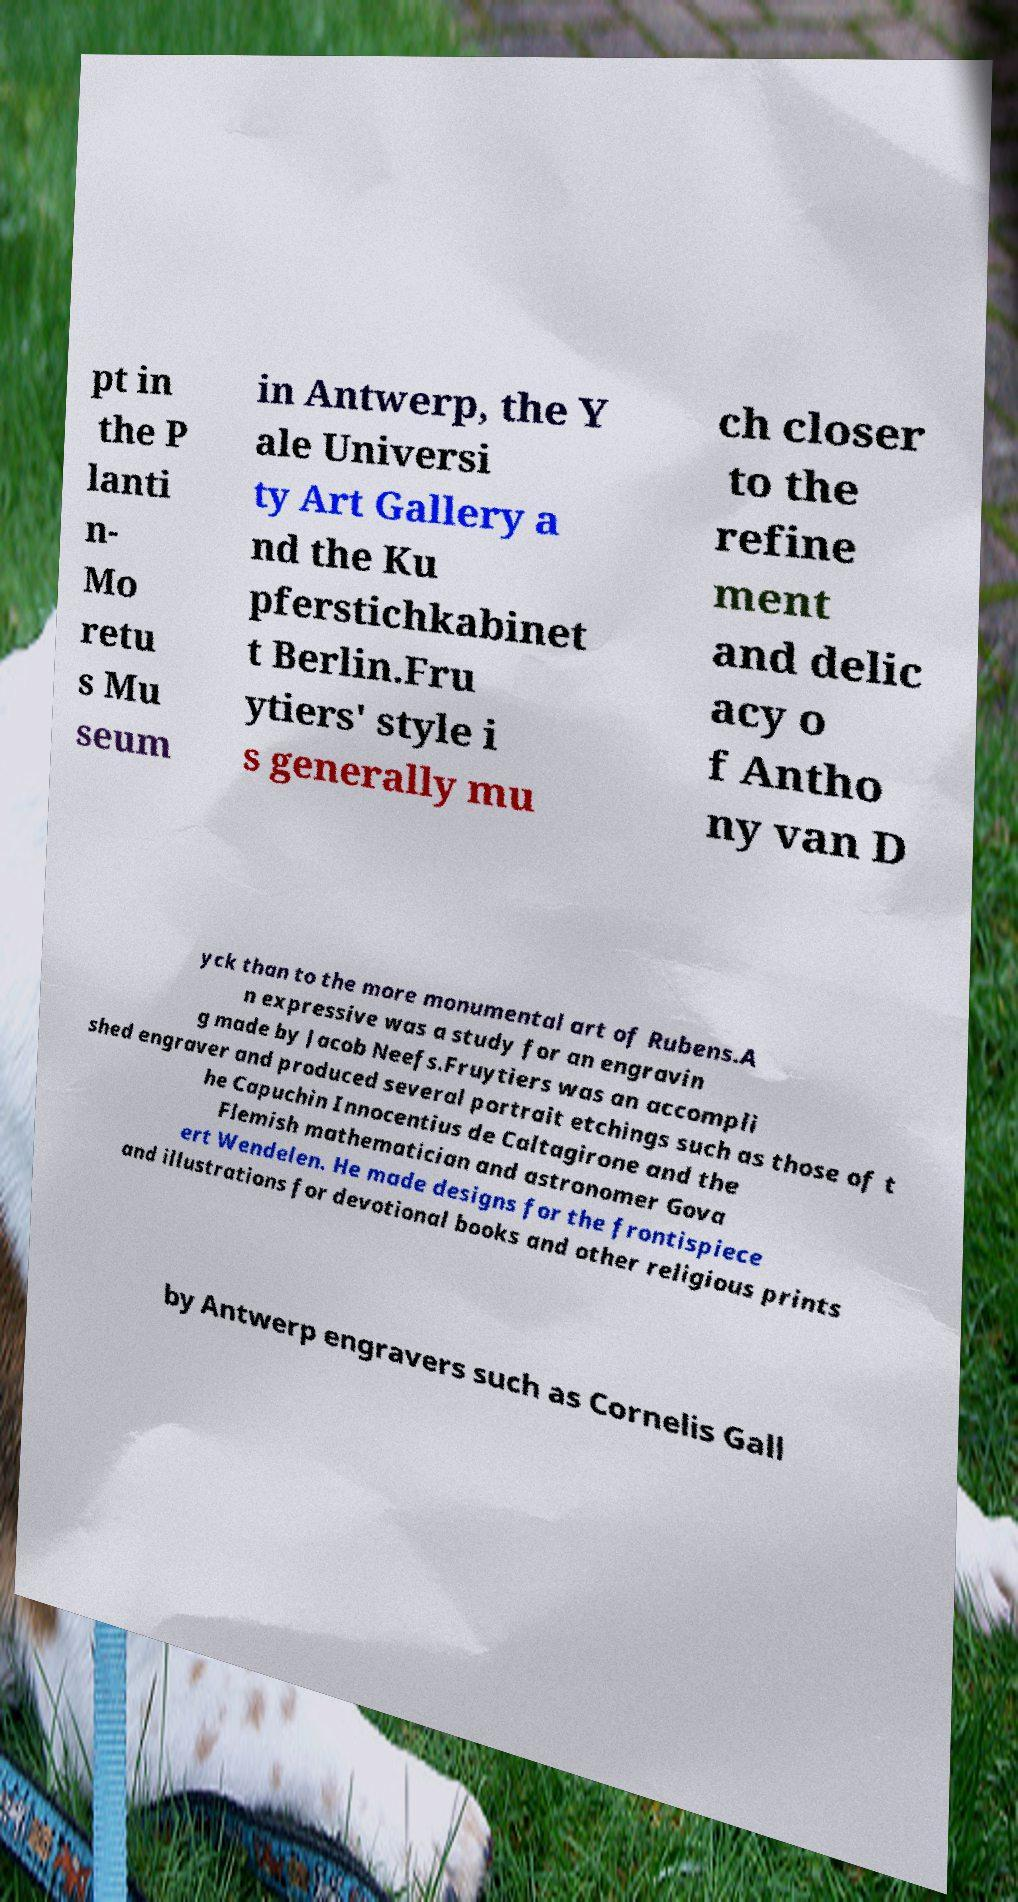Can you accurately transcribe the text from the provided image for me? pt in the P lanti n- Mo retu s Mu seum in Antwerp, the Y ale Universi ty Art Gallery a nd the Ku pferstichkabinet t Berlin.Fru ytiers' style i s generally mu ch closer to the refine ment and delic acy o f Antho ny van D yck than to the more monumental art of Rubens.A n expressive was a study for an engravin g made by Jacob Neefs.Fruytiers was an accompli shed engraver and produced several portrait etchings such as those of t he Capuchin Innocentius de Caltagirone and the Flemish mathematician and astronomer Gova ert Wendelen. He made designs for the frontispiece and illustrations for devotional books and other religious prints by Antwerp engravers such as Cornelis Gall 